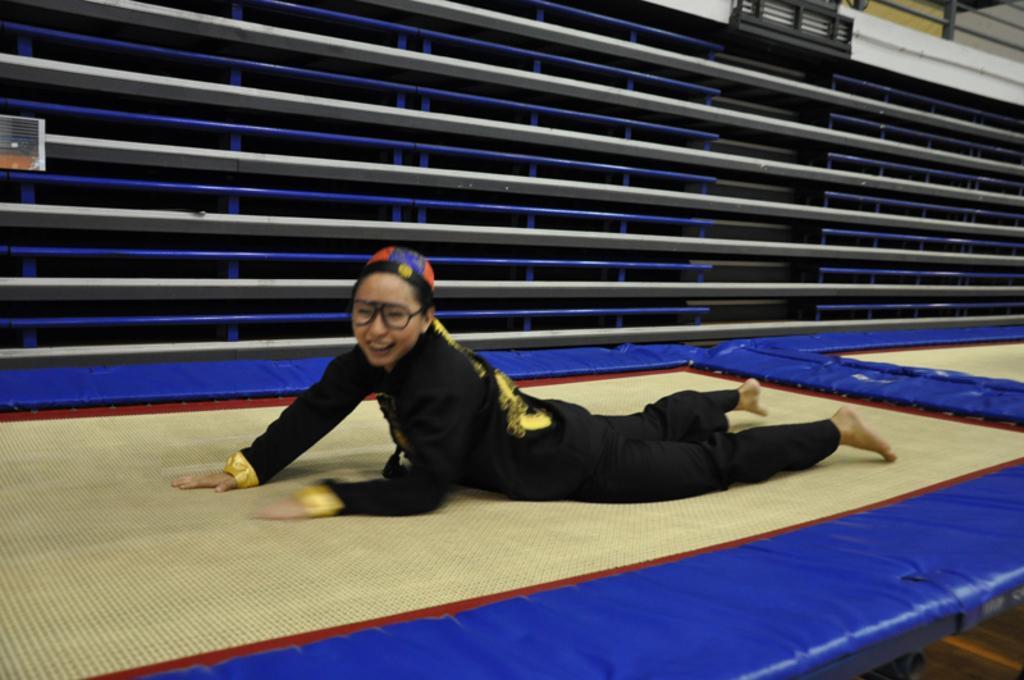Could you give a brief overview of what you see in this image? This image consists of a person. She is a woman. She is lying on the bed. That looks like a mat. 